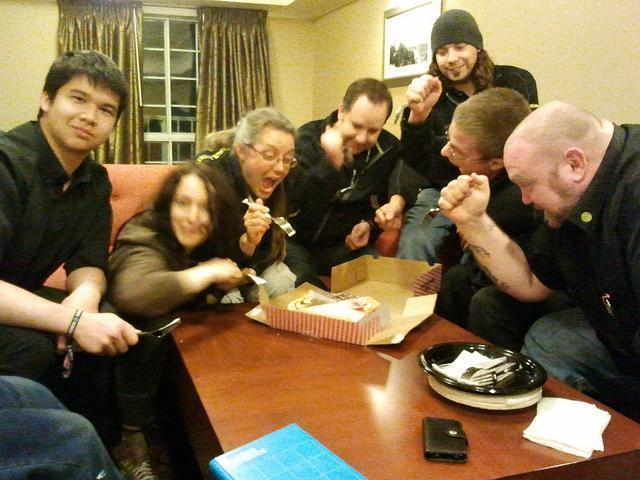How many people are wearing glasses?
Give a very brief answer. 2. How many people are in the picture?
Give a very brief answer. 7. 